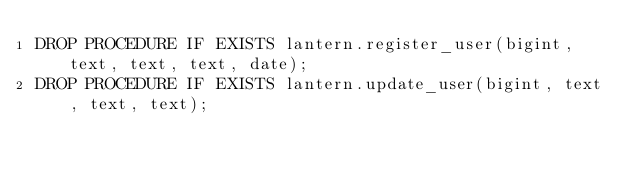Convert code to text. <code><loc_0><loc_0><loc_500><loc_500><_SQL_>DROP PROCEDURE IF EXISTS lantern.register_user(bigint, text, text, text, date);
DROP PROCEDURE IF EXISTS lantern.update_user(bigint, text, text, text);</code> 